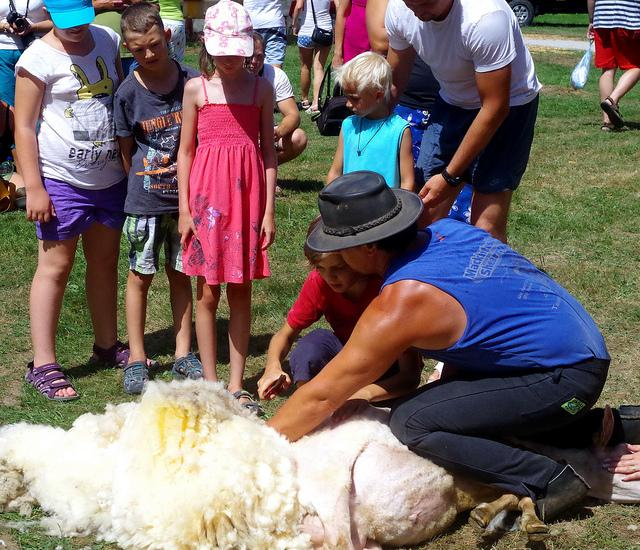Why is the animal on the ground?

Choices:
A) sleeping
B) shearing
C) killing
D) birthing shearing 